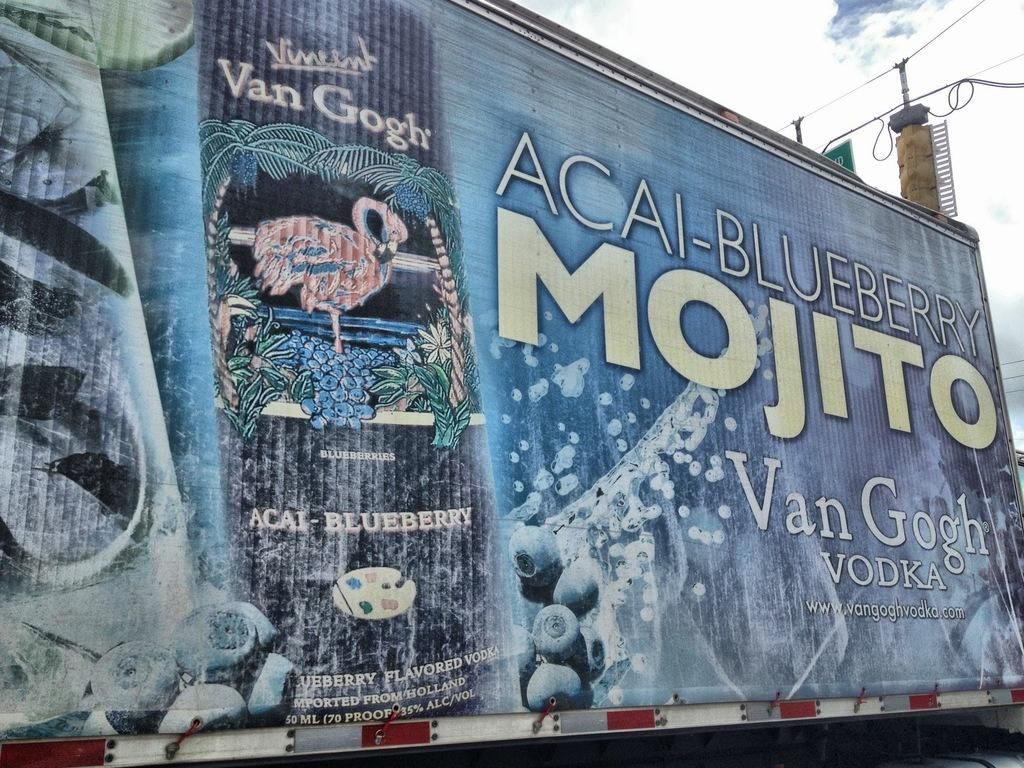<image>
Present a compact description of the photo's key features. a large billboard ad for Acai Blueberry Mojito 